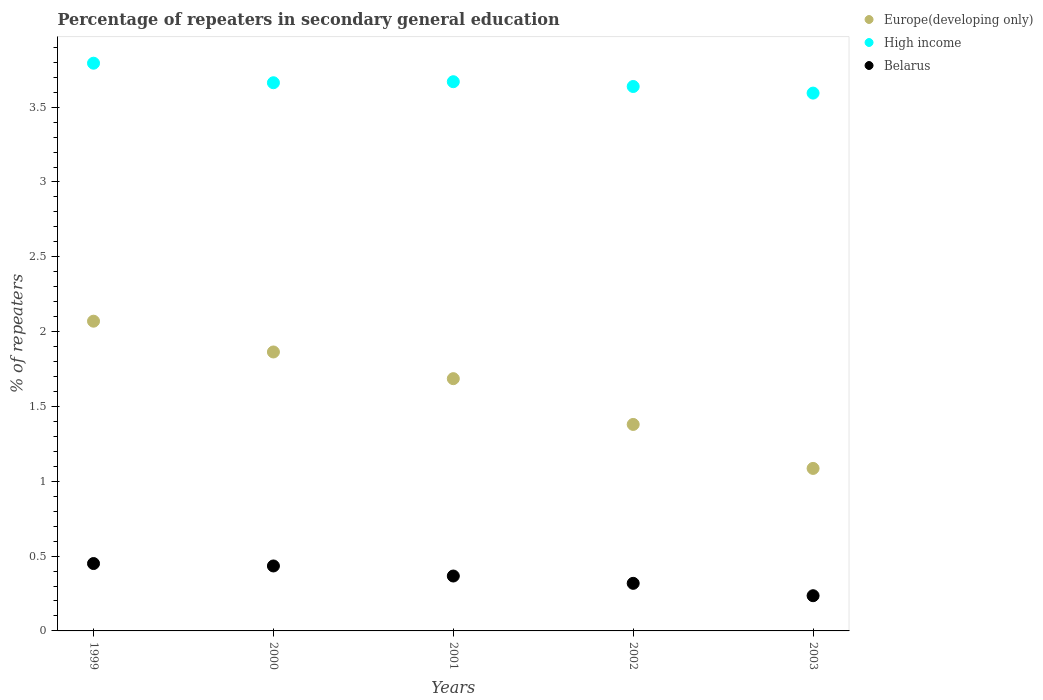Is the number of dotlines equal to the number of legend labels?
Your response must be concise. Yes. What is the percentage of repeaters in secondary general education in High income in 2000?
Keep it short and to the point. 3.66. Across all years, what is the maximum percentage of repeaters in secondary general education in High income?
Your response must be concise. 3.79. Across all years, what is the minimum percentage of repeaters in secondary general education in High income?
Your answer should be compact. 3.59. In which year was the percentage of repeaters in secondary general education in High income minimum?
Make the answer very short. 2003. What is the total percentage of repeaters in secondary general education in Europe(developing only) in the graph?
Your answer should be very brief. 8.09. What is the difference between the percentage of repeaters in secondary general education in High income in 1999 and that in 2003?
Offer a terse response. 0.2. What is the difference between the percentage of repeaters in secondary general education in Europe(developing only) in 2003 and the percentage of repeaters in secondary general education in High income in 2001?
Ensure brevity in your answer.  -2.58. What is the average percentage of repeaters in secondary general education in Europe(developing only) per year?
Provide a succinct answer. 1.62. In the year 2003, what is the difference between the percentage of repeaters in secondary general education in Europe(developing only) and percentage of repeaters in secondary general education in Belarus?
Provide a succinct answer. 0.85. In how many years, is the percentage of repeaters in secondary general education in Europe(developing only) greater than 1.7 %?
Your answer should be compact. 2. What is the ratio of the percentage of repeaters in secondary general education in High income in 1999 to that in 2002?
Offer a very short reply. 1.04. What is the difference between the highest and the second highest percentage of repeaters in secondary general education in High income?
Give a very brief answer. 0.12. What is the difference between the highest and the lowest percentage of repeaters in secondary general education in Europe(developing only)?
Provide a succinct answer. 0.98. Is it the case that in every year, the sum of the percentage of repeaters in secondary general education in Europe(developing only) and percentage of repeaters in secondary general education in Belarus  is greater than the percentage of repeaters in secondary general education in High income?
Offer a very short reply. No. Does the percentage of repeaters in secondary general education in Europe(developing only) monotonically increase over the years?
Keep it short and to the point. No. Is the percentage of repeaters in secondary general education in Europe(developing only) strictly less than the percentage of repeaters in secondary general education in Belarus over the years?
Your answer should be compact. No. How many dotlines are there?
Your answer should be compact. 3. What is the difference between two consecutive major ticks on the Y-axis?
Your answer should be compact. 0.5. Are the values on the major ticks of Y-axis written in scientific E-notation?
Your answer should be compact. No. How are the legend labels stacked?
Your answer should be compact. Vertical. What is the title of the graph?
Provide a succinct answer. Percentage of repeaters in secondary general education. What is the label or title of the Y-axis?
Your answer should be compact. % of repeaters. What is the % of repeaters of Europe(developing only) in 1999?
Provide a short and direct response. 2.07. What is the % of repeaters in High income in 1999?
Offer a very short reply. 3.79. What is the % of repeaters in Belarus in 1999?
Provide a short and direct response. 0.45. What is the % of repeaters of Europe(developing only) in 2000?
Make the answer very short. 1.86. What is the % of repeaters of High income in 2000?
Offer a terse response. 3.66. What is the % of repeaters of Belarus in 2000?
Ensure brevity in your answer.  0.43. What is the % of repeaters of Europe(developing only) in 2001?
Provide a short and direct response. 1.69. What is the % of repeaters in High income in 2001?
Your response must be concise. 3.67. What is the % of repeaters in Belarus in 2001?
Your response must be concise. 0.37. What is the % of repeaters in Europe(developing only) in 2002?
Make the answer very short. 1.38. What is the % of repeaters of High income in 2002?
Give a very brief answer. 3.64. What is the % of repeaters of Belarus in 2002?
Offer a terse response. 0.32. What is the % of repeaters of Europe(developing only) in 2003?
Your answer should be very brief. 1.09. What is the % of repeaters in High income in 2003?
Your response must be concise. 3.59. What is the % of repeaters in Belarus in 2003?
Offer a terse response. 0.24. Across all years, what is the maximum % of repeaters in Europe(developing only)?
Offer a terse response. 2.07. Across all years, what is the maximum % of repeaters of High income?
Keep it short and to the point. 3.79. Across all years, what is the maximum % of repeaters in Belarus?
Make the answer very short. 0.45. Across all years, what is the minimum % of repeaters in Europe(developing only)?
Give a very brief answer. 1.09. Across all years, what is the minimum % of repeaters in High income?
Give a very brief answer. 3.59. Across all years, what is the minimum % of repeaters of Belarus?
Offer a terse response. 0.24. What is the total % of repeaters in Europe(developing only) in the graph?
Your response must be concise. 8.09. What is the total % of repeaters in High income in the graph?
Your answer should be compact. 18.36. What is the total % of repeaters of Belarus in the graph?
Offer a very short reply. 1.8. What is the difference between the % of repeaters in Europe(developing only) in 1999 and that in 2000?
Offer a very short reply. 0.21. What is the difference between the % of repeaters of High income in 1999 and that in 2000?
Give a very brief answer. 0.13. What is the difference between the % of repeaters in Belarus in 1999 and that in 2000?
Your answer should be compact. 0.02. What is the difference between the % of repeaters of Europe(developing only) in 1999 and that in 2001?
Offer a terse response. 0.38. What is the difference between the % of repeaters in High income in 1999 and that in 2001?
Your response must be concise. 0.12. What is the difference between the % of repeaters in Belarus in 1999 and that in 2001?
Offer a very short reply. 0.08. What is the difference between the % of repeaters of Europe(developing only) in 1999 and that in 2002?
Your response must be concise. 0.69. What is the difference between the % of repeaters of High income in 1999 and that in 2002?
Offer a terse response. 0.16. What is the difference between the % of repeaters in Belarus in 1999 and that in 2002?
Your answer should be compact. 0.13. What is the difference between the % of repeaters in Europe(developing only) in 1999 and that in 2003?
Your answer should be very brief. 0.98. What is the difference between the % of repeaters in High income in 1999 and that in 2003?
Provide a succinct answer. 0.2. What is the difference between the % of repeaters in Belarus in 1999 and that in 2003?
Provide a short and direct response. 0.21. What is the difference between the % of repeaters of Europe(developing only) in 2000 and that in 2001?
Keep it short and to the point. 0.18. What is the difference between the % of repeaters of High income in 2000 and that in 2001?
Make the answer very short. -0.01. What is the difference between the % of repeaters of Belarus in 2000 and that in 2001?
Ensure brevity in your answer.  0.07. What is the difference between the % of repeaters of Europe(developing only) in 2000 and that in 2002?
Give a very brief answer. 0.48. What is the difference between the % of repeaters in High income in 2000 and that in 2002?
Ensure brevity in your answer.  0.03. What is the difference between the % of repeaters in Belarus in 2000 and that in 2002?
Give a very brief answer. 0.12. What is the difference between the % of repeaters of Europe(developing only) in 2000 and that in 2003?
Provide a short and direct response. 0.78. What is the difference between the % of repeaters of High income in 2000 and that in 2003?
Your response must be concise. 0.07. What is the difference between the % of repeaters in Belarus in 2000 and that in 2003?
Your answer should be very brief. 0.2. What is the difference between the % of repeaters in Europe(developing only) in 2001 and that in 2002?
Offer a terse response. 0.31. What is the difference between the % of repeaters of High income in 2001 and that in 2002?
Offer a very short reply. 0.03. What is the difference between the % of repeaters of Belarus in 2001 and that in 2002?
Your answer should be compact. 0.05. What is the difference between the % of repeaters of Europe(developing only) in 2001 and that in 2003?
Make the answer very short. 0.6. What is the difference between the % of repeaters of High income in 2001 and that in 2003?
Ensure brevity in your answer.  0.08. What is the difference between the % of repeaters of Belarus in 2001 and that in 2003?
Give a very brief answer. 0.13. What is the difference between the % of repeaters of Europe(developing only) in 2002 and that in 2003?
Ensure brevity in your answer.  0.29. What is the difference between the % of repeaters of High income in 2002 and that in 2003?
Your response must be concise. 0.04. What is the difference between the % of repeaters of Belarus in 2002 and that in 2003?
Make the answer very short. 0.08. What is the difference between the % of repeaters of Europe(developing only) in 1999 and the % of repeaters of High income in 2000?
Your answer should be compact. -1.59. What is the difference between the % of repeaters of Europe(developing only) in 1999 and the % of repeaters of Belarus in 2000?
Make the answer very short. 1.64. What is the difference between the % of repeaters in High income in 1999 and the % of repeaters in Belarus in 2000?
Your answer should be very brief. 3.36. What is the difference between the % of repeaters of Europe(developing only) in 1999 and the % of repeaters of High income in 2001?
Provide a short and direct response. -1.6. What is the difference between the % of repeaters of Europe(developing only) in 1999 and the % of repeaters of Belarus in 2001?
Provide a succinct answer. 1.7. What is the difference between the % of repeaters in High income in 1999 and the % of repeaters in Belarus in 2001?
Provide a succinct answer. 3.43. What is the difference between the % of repeaters in Europe(developing only) in 1999 and the % of repeaters in High income in 2002?
Your response must be concise. -1.57. What is the difference between the % of repeaters of Europe(developing only) in 1999 and the % of repeaters of Belarus in 2002?
Provide a succinct answer. 1.75. What is the difference between the % of repeaters of High income in 1999 and the % of repeaters of Belarus in 2002?
Your answer should be very brief. 3.48. What is the difference between the % of repeaters in Europe(developing only) in 1999 and the % of repeaters in High income in 2003?
Your answer should be compact. -1.52. What is the difference between the % of repeaters in Europe(developing only) in 1999 and the % of repeaters in Belarus in 2003?
Provide a succinct answer. 1.83. What is the difference between the % of repeaters of High income in 1999 and the % of repeaters of Belarus in 2003?
Your answer should be compact. 3.56. What is the difference between the % of repeaters of Europe(developing only) in 2000 and the % of repeaters of High income in 2001?
Offer a very short reply. -1.81. What is the difference between the % of repeaters of Europe(developing only) in 2000 and the % of repeaters of Belarus in 2001?
Give a very brief answer. 1.5. What is the difference between the % of repeaters in High income in 2000 and the % of repeaters in Belarus in 2001?
Your answer should be very brief. 3.3. What is the difference between the % of repeaters in Europe(developing only) in 2000 and the % of repeaters in High income in 2002?
Provide a short and direct response. -1.77. What is the difference between the % of repeaters of Europe(developing only) in 2000 and the % of repeaters of Belarus in 2002?
Your answer should be very brief. 1.55. What is the difference between the % of repeaters in High income in 2000 and the % of repeaters in Belarus in 2002?
Ensure brevity in your answer.  3.35. What is the difference between the % of repeaters of Europe(developing only) in 2000 and the % of repeaters of High income in 2003?
Your response must be concise. -1.73. What is the difference between the % of repeaters of Europe(developing only) in 2000 and the % of repeaters of Belarus in 2003?
Your response must be concise. 1.63. What is the difference between the % of repeaters in High income in 2000 and the % of repeaters in Belarus in 2003?
Provide a succinct answer. 3.43. What is the difference between the % of repeaters in Europe(developing only) in 2001 and the % of repeaters in High income in 2002?
Offer a terse response. -1.95. What is the difference between the % of repeaters in Europe(developing only) in 2001 and the % of repeaters in Belarus in 2002?
Ensure brevity in your answer.  1.37. What is the difference between the % of repeaters in High income in 2001 and the % of repeaters in Belarus in 2002?
Your answer should be compact. 3.35. What is the difference between the % of repeaters of Europe(developing only) in 2001 and the % of repeaters of High income in 2003?
Your response must be concise. -1.91. What is the difference between the % of repeaters in Europe(developing only) in 2001 and the % of repeaters in Belarus in 2003?
Your answer should be compact. 1.45. What is the difference between the % of repeaters in High income in 2001 and the % of repeaters in Belarus in 2003?
Keep it short and to the point. 3.43. What is the difference between the % of repeaters in Europe(developing only) in 2002 and the % of repeaters in High income in 2003?
Make the answer very short. -2.21. What is the difference between the % of repeaters of Europe(developing only) in 2002 and the % of repeaters of Belarus in 2003?
Keep it short and to the point. 1.14. What is the difference between the % of repeaters of High income in 2002 and the % of repeaters of Belarus in 2003?
Provide a succinct answer. 3.4. What is the average % of repeaters in Europe(developing only) per year?
Provide a succinct answer. 1.62. What is the average % of repeaters of High income per year?
Your answer should be very brief. 3.67. What is the average % of repeaters in Belarus per year?
Provide a short and direct response. 0.36. In the year 1999, what is the difference between the % of repeaters in Europe(developing only) and % of repeaters in High income?
Provide a short and direct response. -1.72. In the year 1999, what is the difference between the % of repeaters in Europe(developing only) and % of repeaters in Belarus?
Your answer should be very brief. 1.62. In the year 1999, what is the difference between the % of repeaters of High income and % of repeaters of Belarus?
Your answer should be compact. 3.34. In the year 2000, what is the difference between the % of repeaters in Europe(developing only) and % of repeaters in High income?
Give a very brief answer. -1.8. In the year 2000, what is the difference between the % of repeaters in Europe(developing only) and % of repeaters in Belarus?
Offer a terse response. 1.43. In the year 2000, what is the difference between the % of repeaters in High income and % of repeaters in Belarus?
Offer a terse response. 3.23. In the year 2001, what is the difference between the % of repeaters of Europe(developing only) and % of repeaters of High income?
Your response must be concise. -1.98. In the year 2001, what is the difference between the % of repeaters of Europe(developing only) and % of repeaters of Belarus?
Your answer should be very brief. 1.32. In the year 2001, what is the difference between the % of repeaters of High income and % of repeaters of Belarus?
Provide a short and direct response. 3.3. In the year 2002, what is the difference between the % of repeaters in Europe(developing only) and % of repeaters in High income?
Offer a terse response. -2.26. In the year 2002, what is the difference between the % of repeaters of Europe(developing only) and % of repeaters of Belarus?
Provide a succinct answer. 1.06. In the year 2002, what is the difference between the % of repeaters in High income and % of repeaters in Belarus?
Your answer should be compact. 3.32. In the year 2003, what is the difference between the % of repeaters in Europe(developing only) and % of repeaters in High income?
Your answer should be compact. -2.51. In the year 2003, what is the difference between the % of repeaters of Europe(developing only) and % of repeaters of Belarus?
Offer a very short reply. 0.85. In the year 2003, what is the difference between the % of repeaters in High income and % of repeaters in Belarus?
Keep it short and to the point. 3.36. What is the ratio of the % of repeaters of Europe(developing only) in 1999 to that in 2000?
Provide a succinct answer. 1.11. What is the ratio of the % of repeaters in High income in 1999 to that in 2000?
Offer a terse response. 1.04. What is the ratio of the % of repeaters of Belarus in 1999 to that in 2000?
Offer a terse response. 1.04. What is the ratio of the % of repeaters of Europe(developing only) in 1999 to that in 2001?
Provide a short and direct response. 1.23. What is the ratio of the % of repeaters in High income in 1999 to that in 2001?
Keep it short and to the point. 1.03. What is the ratio of the % of repeaters of Belarus in 1999 to that in 2001?
Give a very brief answer. 1.23. What is the ratio of the % of repeaters of High income in 1999 to that in 2002?
Provide a succinct answer. 1.04. What is the ratio of the % of repeaters of Belarus in 1999 to that in 2002?
Keep it short and to the point. 1.42. What is the ratio of the % of repeaters in Europe(developing only) in 1999 to that in 2003?
Your answer should be very brief. 1.91. What is the ratio of the % of repeaters of High income in 1999 to that in 2003?
Offer a terse response. 1.06. What is the ratio of the % of repeaters of Belarus in 1999 to that in 2003?
Ensure brevity in your answer.  1.91. What is the ratio of the % of repeaters in Europe(developing only) in 2000 to that in 2001?
Offer a terse response. 1.11. What is the ratio of the % of repeaters in Belarus in 2000 to that in 2001?
Your answer should be compact. 1.18. What is the ratio of the % of repeaters in Europe(developing only) in 2000 to that in 2002?
Your answer should be compact. 1.35. What is the ratio of the % of repeaters of Belarus in 2000 to that in 2002?
Give a very brief answer. 1.36. What is the ratio of the % of repeaters in Europe(developing only) in 2000 to that in 2003?
Your answer should be compact. 1.72. What is the ratio of the % of repeaters of High income in 2000 to that in 2003?
Make the answer very short. 1.02. What is the ratio of the % of repeaters of Belarus in 2000 to that in 2003?
Offer a terse response. 1.85. What is the ratio of the % of repeaters of Europe(developing only) in 2001 to that in 2002?
Offer a very short reply. 1.22. What is the ratio of the % of repeaters of High income in 2001 to that in 2002?
Provide a succinct answer. 1.01. What is the ratio of the % of repeaters in Belarus in 2001 to that in 2002?
Your answer should be compact. 1.15. What is the ratio of the % of repeaters in Europe(developing only) in 2001 to that in 2003?
Give a very brief answer. 1.55. What is the ratio of the % of repeaters in High income in 2001 to that in 2003?
Offer a very short reply. 1.02. What is the ratio of the % of repeaters in Belarus in 2001 to that in 2003?
Give a very brief answer. 1.56. What is the ratio of the % of repeaters in Europe(developing only) in 2002 to that in 2003?
Give a very brief answer. 1.27. What is the ratio of the % of repeaters of High income in 2002 to that in 2003?
Keep it short and to the point. 1.01. What is the ratio of the % of repeaters in Belarus in 2002 to that in 2003?
Provide a succinct answer. 1.35. What is the difference between the highest and the second highest % of repeaters of Europe(developing only)?
Offer a terse response. 0.21. What is the difference between the highest and the second highest % of repeaters in High income?
Ensure brevity in your answer.  0.12. What is the difference between the highest and the second highest % of repeaters in Belarus?
Your answer should be compact. 0.02. What is the difference between the highest and the lowest % of repeaters of Europe(developing only)?
Offer a very short reply. 0.98. What is the difference between the highest and the lowest % of repeaters in High income?
Ensure brevity in your answer.  0.2. What is the difference between the highest and the lowest % of repeaters in Belarus?
Your answer should be compact. 0.21. 